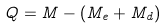Convert formula to latex. <formula><loc_0><loc_0><loc_500><loc_500>Q = M - ( M _ { e } + M _ { d } )</formula> 